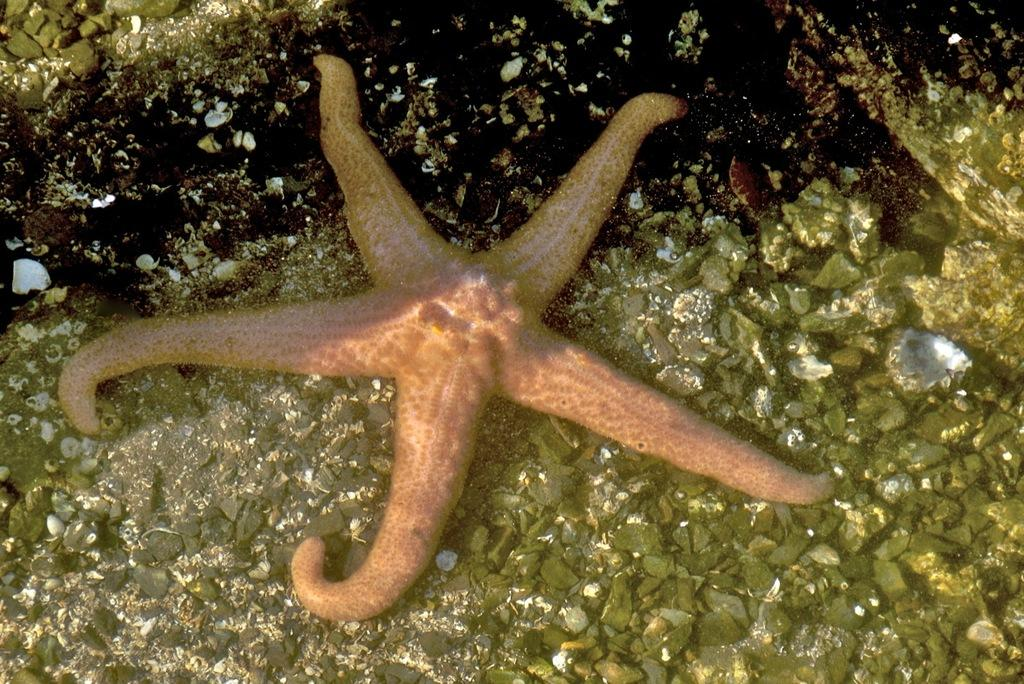What type of marine animal can be seen in the water in the image? There is a starfish in the water in the image. What other objects can be seen in the water? There are many pebbles and a few shells in the water. What type of plantation can be seen in the background of the image? There is no plantation visible in the image; it features a starfish, pebbles, and shells in the water. How many cherries are present in the image? There are no cherries present in the image. 